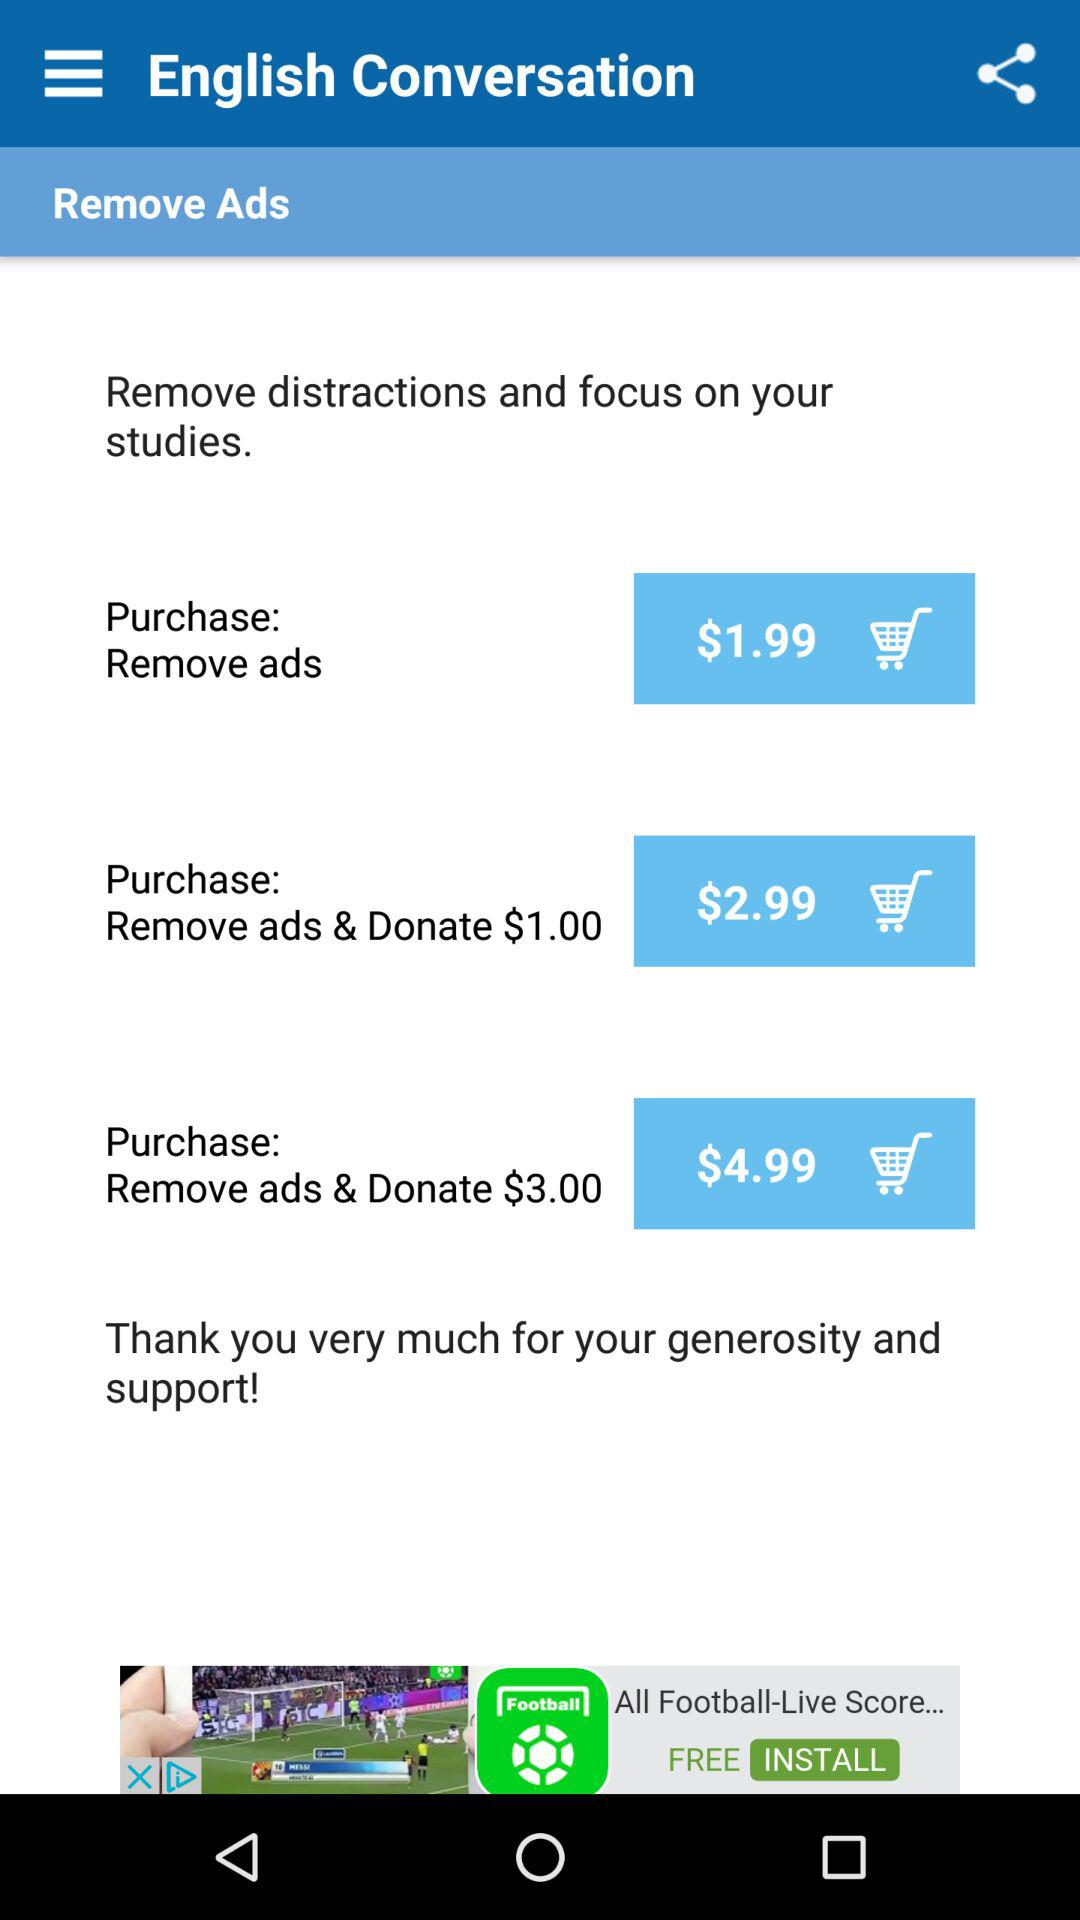What is the price to remove advertisements? The price is $1.99. 